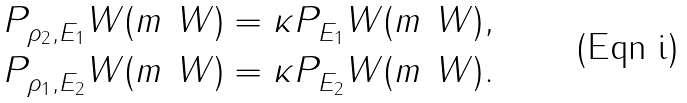Convert formula to latex. <formula><loc_0><loc_0><loc_500><loc_500>P _ { \rho _ { 2 } , E _ { 1 } } ^ { \ } W ( m ^ { \ } W ) & = \kappa P _ { E _ { 1 } } ^ { \ } W ( m ^ { \ } W ) , \\ P _ { \rho _ { 1 } , E _ { 2 } } ^ { \ } W ( m ^ { \ } W ) & = \kappa P _ { E _ { 2 } } ^ { \ } W ( m ^ { \ } W ) .</formula> 